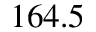<formula> <loc_0><loc_0><loc_500><loc_500>1 6 4 . 5</formula> 